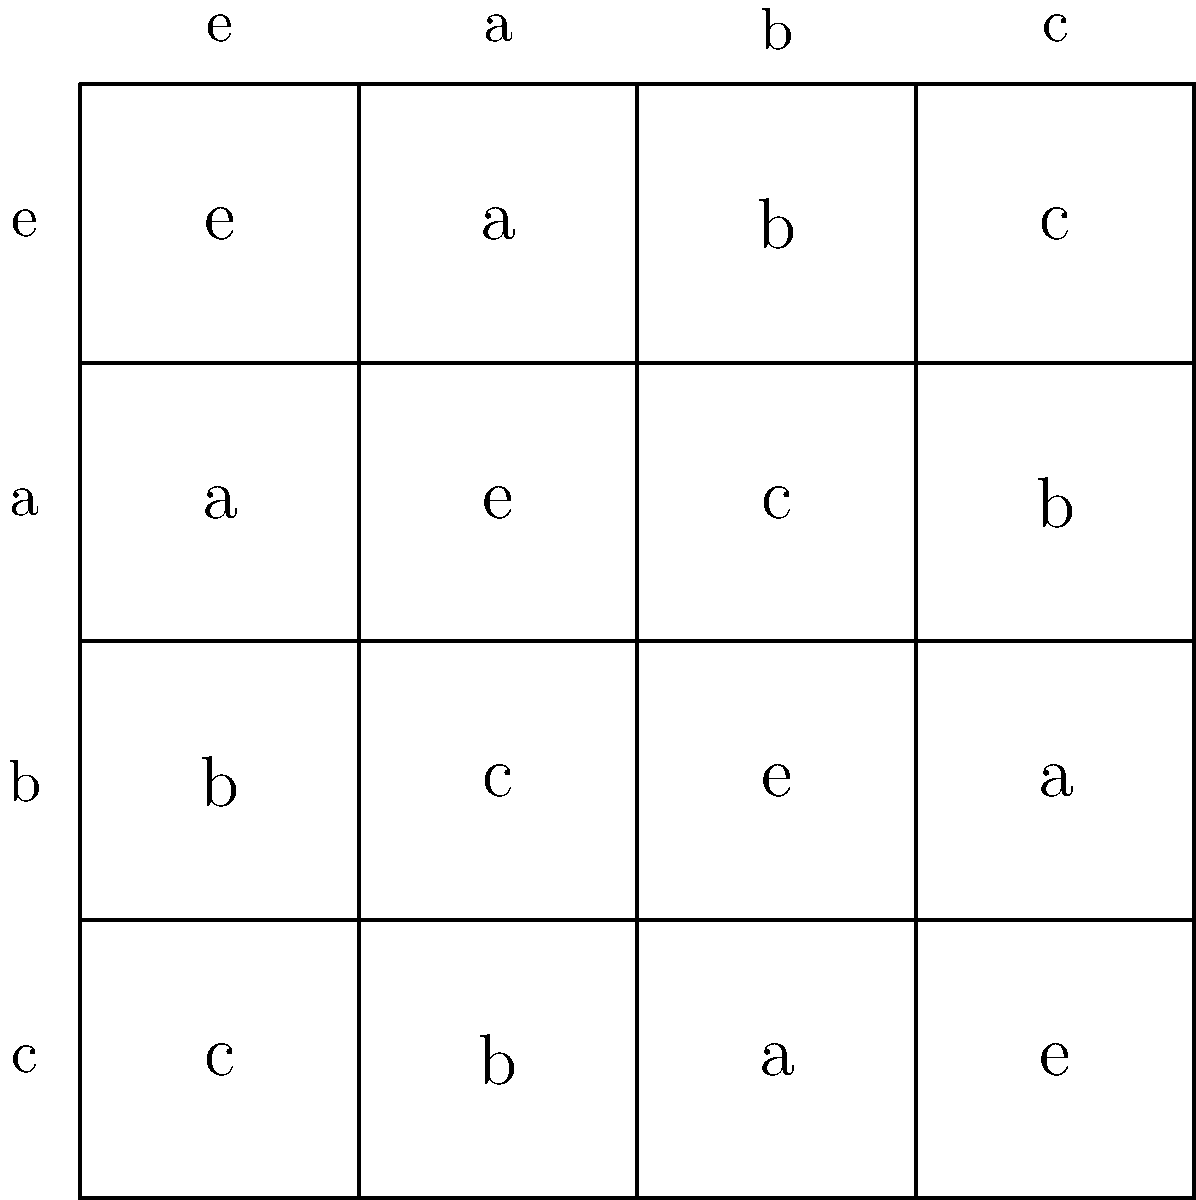Consider the Cayley table of a group with four elements as shown in the image. What ethical implications might arise from using such abstract mathematical structures to model real-world decision-making processes in fields like artificial intelligence or policy-making? To answer this question, we need to consider several aspects:

1. Abstract representation: The Cayley table represents a finite group with four elements (e, a, b, c). It shows how these elements interact under the group operation.

2. Properties of the group:
   - Closure: The result of any operation is always within the group.
   - Associativity: (x * y) * z = x * (y * z) for all elements.
   - Identity element: 'e' acts as the identity.
   - Inverse: Each element has an inverse (e.g., a * a = e).

3. Application to decision-making:
   - Simplification: Complex real-world scenarios might be oversimplified when modeled using such structures.
   - Determinism: The table implies that outcomes are predetermined and finite.
   - Reversibility: Every action has a defined inverse, which may not be true in reality.

4. Ethical considerations:
   - Reductionism: Reducing human behavior or societal issues to mathematical models may overlook important nuances.
   - Bias: The choice of group structure could introduce biases in decision-making algorithms.
   - Transparency: The abstract nature of the model might make it difficult for non-experts to understand and scrutinize.
   - Accountability: If decisions are based on such models, who is responsible for unintended consequences?
   - Fairness: The model assumes all elements are equally important, which may not reflect real-world power dynamics.

5. Potential benefits:
   - Consistency: Mathematical models can provide consistent frameworks for decision-making.
   - Objectivity: Abstract structures can help remove some forms of human bias.
   - Efficiency: Such models can enable rapid decision-making in complex scenarios.

The ethical implications stem from the tension between the benefits of using such abstract models and the risks of oversimplification or misapplication in contexts that affect human lives and society.
Answer: Ethical concerns include reductionism, potential bias, lack of transparency, accountability issues, and fairness considerations, balanced against benefits of consistency, objectivity, and efficiency in decision-making processes. 